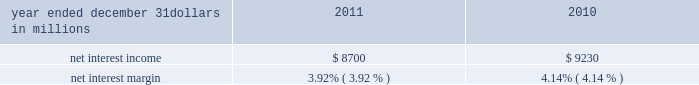Corporate & institutional banking corporate & institutional banking earned $ 1.9 billion in 2011 and $ 1.8 billion in 2010 .
The increase in earnings was primarily due to an improvement in the provision for credit losses , which was a benefit in 2011 , partially offset by a reduction in the value of commercial mortgage servicing rights and lower net interest income .
We continued to focus on adding new clients , increasing cross sales , and remaining committed to strong expense discipline .
Asset management group asset management group earned $ 141 million for 2011 compared with $ 137 million for 2010 .
Assets under administration were $ 210 billion at december 31 , 2011 and $ 212 billion at december 31 , 2010 .
Earnings for 2011 reflected a benefit from the provision for credit losses and growth in noninterest income , partially offset by higher noninterest expense and lower net interest income .
For 2011 , the business delivered strong sales production , grew high value clients and benefitted from significant referrals from other pnc lines of business .
Over time and with stabilized market conditions , the successful execution of these strategies and the accumulation of our strong sales performance are expected to create meaningful growth in assets under management and noninterest income .
Residential mortgage banking residential mortgage banking earned $ 87 million in 2011 compared with $ 269 million in 2010 .
The decline in earnings was driven by an increase in noninterest expense associated with increased costs for residential mortgage foreclosure- related expenses , primarily as a result of ongoing governmental matters , and lower net interest income , partially offset by an increase in loan originations and higher loans sales revenue .
Blackrock our blackrock business segment earned $ 361 million in 2011 and $ 351 million in 2010 .
The higher business segment earnings from blackrock for 2011 compared with 2010 were primarily due to an increase in revenue .
Non-strategic assets portfolio this business segment ( formerly distressed assets portfolio ) consists primarily of acquired non-strategic assets that fall outside of our core business strategy .
Non-strategic assets portfolio had earnings of $ 200 million in 2011 compared with a loss of $ 57 million in 2010 .
The increase was primarily attributable to a lower provision for credit losses partially offset by lower net interest income .
201cother 201d reported earnings of $ 376 million for 2011 compared with earnings of $ 386 million for 2010 .
The decrease in earnings primarily reflected the noncash charge related to the redemption of trust preferred securities in the fourth quarter of 2011 and the gain related to the sale of a portion of pnc 2019s blackrock shares in 2010 partially offset by lower integration costs in 2011 .
Consolidated income statement review our consolidated income statement is presented in item 8 of this report .
Net income for 2011 was $ 3.1 billion compared with $ 3.4 billion for 2010 .
Results for 2011 include the impact of $ 324 million of residential mortgage foreclosure-related expenses primarily as a result of ongoing governmental matters , a $ 198 million noncash charge related to redemption of trust preferred securities and $ 42 million for integration costs .
Results for 2010 included the $ 328 million after-tax gain on our sale of gis , $ 387 million for integration costs , and $ 71 million of residential mortgage foreclosure-related expenses .
For 2010 , net income attributable to common shareholders was also impacted by a noncash reduction of $ 250 million in connection with the redemption of tarp preferred stock .
Pnc 2019s results for 2011 were driven by good performance in a challenging environment of low interest rates , slow economic growth and new regulations .
Net interest income and net interest margin year ended december 31 dollars in millions 2011 2010 .
Changes in net interest income and margin result from the interaction of the volume and composition of interest-earning assets and related yields , interest-bearing liabilities and related rates paid , and noninterest-bearing sources of funding .
See the statistical information ( unaudited ) 2013 analysis of year-to-year changes in net interest income and average consolidated balance sheet and net interest analysis in item 8 and the discussion of purchase accounting accretion in the consolidated balance sheet review in item 7 of this report for additional information .
The decreases in net interest income and net interest margin for 2011 compared with 2010 were primarily attributable to a decrease in purchase accounting accretion on purchased impaired loans primarily due to lower excess cash recoveries .
A decline in average loan balances and the low interest rate environment , partially offset by lower funding costs , also contributed to the decrease .
The pnc financial services group , inc .
2013 form 10-k 35 .
In 2011 and 2010 what was the average net interest income in millions? 
Computations: (((8700 + 9230) + 2) / 2)
Answer: 8966.0. 